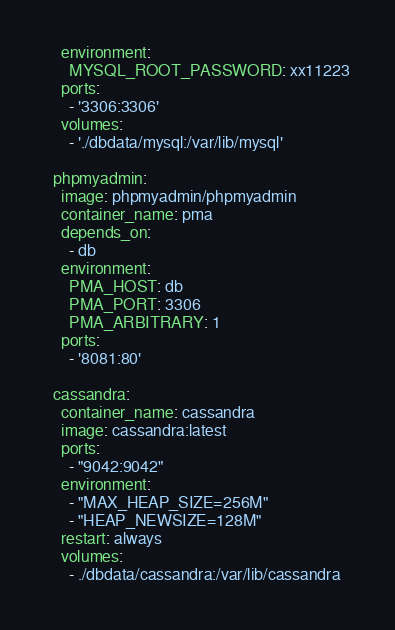Convert code to text. <code><loc_0><loc_0><loc_500><loc_500><_YAML_>    environment:
      MYSQL_ROOT_PASSWORD: xx11223
    ports:
      - '3306:3306'
    volumes:
      - './dbdata/mysql:/var/lib/mysql'
      
  phpmyadmin:
    image: phpmyadmin/phpmyadmin
    container_name: pma
    depends_on:
      - db
    environment:
      PMA_HOST: db
      PMA_PORT: 3306
      PMA_ARBITRARY: 1
    ports:
      - '8081:80'

  cassandra:
    container_name: cassandra
    image: cassandra:latest
    ports:
      - "9042:9042"
    environment:
      - "MAX_HEAP_SIZE=256M"
      - "HEAP_NEWSIZE=128M"
    restart: always
    volumes:
      - ./dbdata/cassandra:/var/lib/cassandra
</code> 